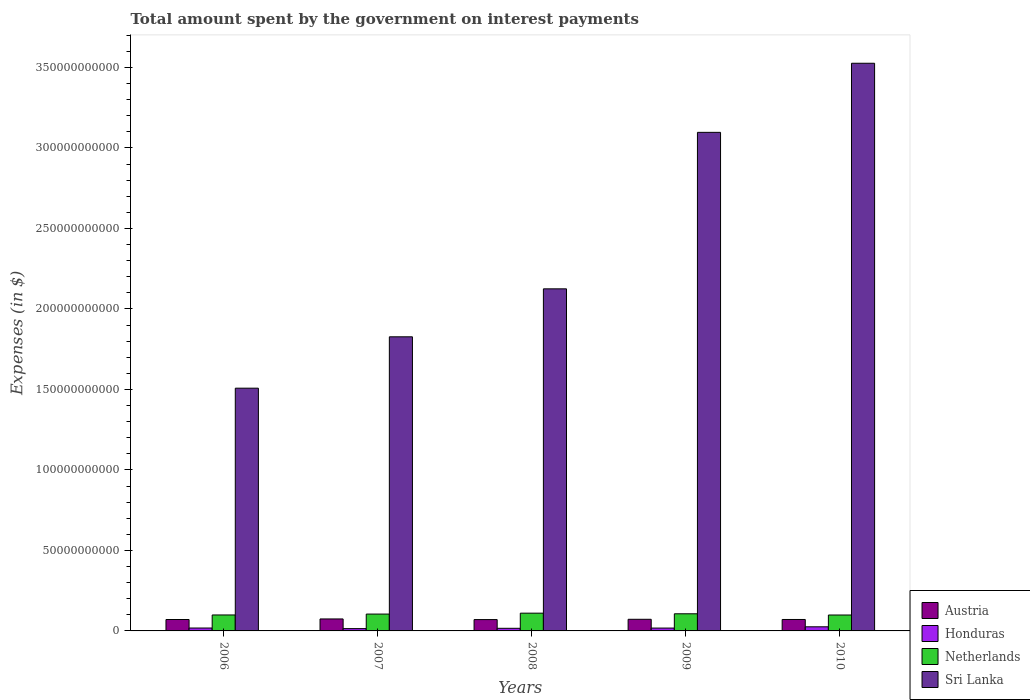How many different coloured bars are there?
Offer a very short reply. 4. Are the number of bars per tick equal to the number of legend labels?
Make the answer very short. Yes. Are the number of bars on each tick of the X-axis equal?
Provide a short and direct response. Yes. How many bars are there on the 1st tick from the left?
Your answer should be very brief. 4. How many bars are there on the 5th tick from the right?
Your answer should be compact. 4. What is the label of the 3rd group of bars from the left?
Make the answer very short. 2008. In how many cases, is the number of bars for a given year not equal to the number of legend labels?
Make the answer very short. 0. What is the amount spent on interest payments by the government in Netherlands in 2009?
Provide a short and direct response. 1.06e+1. Across all years, what is the maximum amount spent on interest payments by the government in Austria?
Your answer should be very brief. 7.44e+09. Across all years, what is the minimum amount spent on interest payments by the government in Austria?
Ensure brevity in your answer.  7.04e+09. What is the total amount spent on interest payments by the government in Sri Lanka in the graph?
Your response must be concise. 1.21e+12. What is the difference between the amount spent on interest payments by the government in Austria in 2006 and that in 2010?
Offer a terse response. -2.66e+07. What is the difference between the amount spent on interest payments by the government in Sri Lanka in 2008 and the amount spent on interest payments by the government in Honduras in 2006?
Your answer should be very brief. 2.11e+11. What is the average amount spent on interest payments by the government in Honduras per year?
Ensure brevity in your answer.  1.84e+09. In the year 2006, what is the difference between the amount spent on interest payments by the government in Honduras and amount spent on interest payments by the government in Netherlands?
Provide a succinct answer. -8.11e+09. What is the ratio of the amount spent on interest payments by the government in Austria in 2006 to that in 2009?
Keep it short and to the point. 0.98. What is the difference between the highest and the second highest amount spent on interest payments by the government in Austria?
Keep it short and to the point. 2.08e+08. What is the difference between the highest and the lowest amount spent on interest payments by the government in Netherlands?
Keep it short and to the point. 1.15e+09. In how many years, is the amount spent on interest payments by the government in Sri Lanka greater than the average amount spent on interest payments by the government in Sri Lanka taken over all years?
Keep it short and to the point. 2. What does the 2nd bar from the left in 2010 represents?
Offer a terse response. Honduras. What does the 2nd bar from the right in 2009 represents?
Provide a short and direct response. Netherlands. Is it the case that in every year, the sum of the amount spent on interest payments by the government in Sri Lanka and amount spent on interest payments by the government in Austria is greater than the amount spent on interest payments by the government in Netherlands?
Make the answer very short. Yes. Are all the bars in the graph horizontal?
Your response must be concise. No. Does the graph contain grids?
Give a very brief answer. No. Where does the legend appear in the graph?
Provide a short and direct response. Bottom right. What is the title of the graph?
Provide a short and direct response. Total amount spent by the government on interest payments. Does "Canada" appear as one of the legend labels in the graph?
Ensure brevity in your answer.  No. What is the label or title of the Y-axis?
Provide a succinct answer. Expenses (in $). What is the Expenses (in $) in Austria in 2006?
Give a very brief answer. 7.09e+09. What is the Expenses (in $) in Honduras in 2006?
Your response must be concise. 1.80e+09. What is the Expenses (in $) in Netherlands in 2006?
Make the answer very short. 9.91e+09. What is the Expenses (in $) in Sri Lanka in 2006?
Ensure brevity in your answer.  1.51e+11. What is the Expenses (in $) in Austria in 2007?
Ensure brevity in your answer.  7.44e+09. What is the Expenses (in $) in Honduras in 2007?
Your answer should be very brief. 1.43e+09. What is the Expenses (in $) of Netherlands in 2007?
Offer a very short reply. 1.05e+1. What is the Expenses (in $) of Sri Lanka in 2007?
Your answer should be compact. 1.83e+11. What is the Expenses (in $) in Austria in 2008?
Ensure brevity in your answer.  7.04e+09. What is the Expenses (in $) of Honduras in 2008?
Your answer should be compact. 1.63e+09. What is the Expenses (in $) in Netherlands in 2008?
Your answer should be very brief. 1.10e+1. What is the Expenses (in $) in Sri Lanka in 2008?
Your answer should be very brief. 2.12e+11. What is the Expenses (in $) of Austria in 2009?
Make the answer very short. 7.23e+09. What is the Expenses (in $) of Honduras in 2009?
Offer a very short reply. 1.77e+09. What is the Expenses (in $) of Netherlands in 2009?
Provide a short and direct response. 1.06e+1. What is the Expenses (in $) of Sri Lanka in 2009?
Offer a very short reply. 3.10e+11. What is the Expenses (in $) in Austria in 2010?
Make the answer very short. 7.11e+09. What is the Expenses (in $) of Honduras in 2010?
Offer a terse response. 2.55e+09. What is the Expenses (in $) in Netherlands in 2010?
Provide a succinct answer. 9.88e+09. What is the Expenses (in $) of Sri Lanka in 2010?
Your response must be concise. 3.53e+11. Across all years, what is the maximum Expenses (in $) in Austria?
Keep it short and to the point. 7.44e+09. Across all years, what is the maximum Expenses (in $) of Honduras?
Offer a terse response. 2.55e+09. Across all years, what is the maximum Expenses (in $) in Netherlands?
Your answer should be very brief. 1.10e+1. Across all years, what is the maximum Expenses (in $) of Sri Lanka?
Offer a very short reply. 3.53e+11. Across all years, what is the minimum Expenses (in $) in Austria?
Keep it short and to the point. 7.04e+09. Across all years, what is the minimum Expenses (in $) in Honduras?
Keep it short and to the point. 1.43e+09. Across all years, what is the minimum Expenses (in $) in Netherlands?
Your response must be concise. 9.88e+09. Across all years, what is the minimum Expenses (in $) in Sri Lanka?
Keep it short and to the point. 1.51e+11. What is the total Expenses (in $) of Austria in the graph?
Your response must be concise. 3.59e+1. What is the total Expenses (in $) in Honduras in the graph?
Your answer should be compact. 9.19e+09. What is the total Expenses (in $) of Netherlands in the graph?
Give a very brief answer. 5.19e+1. What is the total Expenses (in $) of Sri Lanka in the graph?
Your answer should be very brief. 1.21e+12. What is the difference between the Expenses (in $) in Austria in 2006 and that in 2007?
Make the answer very short. -3.51e+08. What is the difference between the Expenses (in $) in Honduras in 2006 and that in 2007?
Offer a terse response. 3.70e+08. What is the difference between the Expenses (in $) in Netherlands in 2006 and that in 2007?
Your response must be concise. -5.60e+08. What is the difference between the Expenses (in $) of Sri Lanka in 2006 and that in 2007?
Your answer should be compact. -3.19e+1. What is the difference between the Expenses (in $) of Austria in 2006 and that in 2008?
Give a very brief answer. 4.10e+07. What is the difference between the Expenses (in $) in Honduras in 2006 and that in 2008?
Provide a succinct answer. 1.78e+08. What is the difference between the Expenses (in $) of Netherlands in 2006 and that in 2008?
Provide a short and direct response. -1.12e+09. What is the difference between the Expenses (in $) in Sri Lanka in 2006 and that in 2008?
Your response must be concise. -6.17e+1. What is the difference between the Expenses (in $) in Austria in 2006 and that in 2009?
Your answer should be very brief. -1.43e+08. What is the difference between the Expenses (in $) of Honduras in 2006 and that in 2009?
Your response must be concise. 2.83e+07. What is the difference between the Expenses (in $) of Netherlands in 2006 and that in 2009?
Provide a succinct answer. -7.34e+08. What is the difference between the Expenses (in $) of Sri Lanka in 2006 and that in 2009?
Provide a succinct answer. -1.59e+11. What is the difference between the Expenses (in $) in Austria in 2006 and that in 2010?
Ensure brevity in your answer.  -2.66e+07. What is the difference between the Expenses (in $) in Honduras in 2006 and that in 2010?
Your answer should be compact. -7.51e+08. What is the difference between the Expenses (in $) in Netherlands in 2006 and that in 2010?
Make the answer very short. 2.60e+07. What is the difference between the Expenses (in $) of Sri Lanka in 2006 and that in 2010?
Your response must be concise. -2.02e+11. What is the difference between the Expenses (in $) of Austria in 2007 and that in 2008?
Make the answer very short. 3.92e+08. What is the difference between the Expenses (in $) in Honduras in 2007 and that in 2008?
Provide a succinct answer. -1.92e+08. What is the difference between the Expenses (in $) of Netherlands in 2007 and that in 2008?
Provide a short and direct response. -5.60e+08. What is the difference between the Expenses (in $) in Sri Lanka in 2007 and that in 2008?
Ensure brevity in your answer.  -2.98e+1. What is the difference between the Expenses (in $) of Austria in 2007 and that in 2009?
Provide a short and direct response. 2.08e+08. What is the difference between the Expenses (in $) in Honduras in 2007 and that in 2009?
Your answer should be compact. -3.41e+08. What is the difference between the Expenses (in $) in Netherlands in 2007 and that in 2009?
Your answer should be compact. -1.74e+08. What is the difference between the Expenses (in $) of Sri Lanka in 2007 and that in 2009?
Your answer should be very brief. -1.27e+11. What is the difference between the Expenses (in $) of Austria in 2007 and that in 2010?
Your answer should be compact. 3.25e+08. What is the difference between the Expenses (in $) of Honduras in 2007 and that in 2010?
Offer a terse response. -1.12e+09. What is the difference between the Expenses (in $) of Netherlands in 2007 and that in 2010?
Your response must be concise. 5.86e+08. What is the difference between the Expenses (in $) in Sri Lanka in 2007 and that in 2010?
Ensure brevity in your answer.  -1.70e+11. What is the difference between the Expenses (in $) in Austria in 2008 and that in 2009?
Provide a succinct answer. -1.84e+08. What is the difference between the Expenses (in $) of Honduras in 2008 and that in 2009?
Your answer should be compact. -1.49e+08. What is the difference between the Expenses (in $) in Netherlands in 2008 and that in 2009?
Your answer should be compact. 3.86e+08. What is the difference between the Expenses (in $) in Sri Lanka in 2008 and that in 2009?
Ensure brevity in your answer.  -9.72e+1. What is the difference between the Expenses (in $) in Austria in 2008 and that in 2010?
Make the answer very short. -6.76e+07. What is the difference between the Expenses (in $) of Honduras in 2008 and that in 2010?
Keep it short and to the point. -9.29e+08. What is the difference between the Expenses (in $) of Netherlands in 2008 and that in 2010?
Ensure brevity in your answer.  1.15e+09. What is the difference between the Expenses (in $) in Sri Lanka in 2008 and that in 2010?
Offer a very short reply. -1.40e+11. What is the difference between the Expenses (in $) in Austria in 2009 and that in 2010?
Provide a short and direct response. 1.17e+08. What is the difference between the Expenses (in $) in Honduras in 2009 and that in 2010?
Your response must be concise. -7.80e+08. What is the difference between the Expenses (in $) in Netherlands in 2009 and that in 2010?
Give a very brief answer. 7.60e+08. What is the difference between the Expenses (in $) of Sri Lanka in 2009 and that in 2010?
Ensure brevity in your answer.  -4.29e+1. What is the difference between the Expenses (in $) of Austria in 2006 and the Expenses (in $) of Honduras in 2007?
Ensure brevity in your answer.  5.65e+09. What is the difference between the Expenses (in $) in Austria in 2006 and the Expenses (in $) in Netherlands in 2007?
Keep it short and to the point. -3.39e+09. What is the difference between the Expenses (in $) in Austria in 2006 and the Expenses (in $) in Sri Lanka in 2007?
Give a very brief answer. -1.76e+11. What is the difference between the Expenses (in $) of Honduras in 2006 and the Expenses (in $) of Netherlands in 2007?
Provide a short and direct response. -8.67e+09. What is the difference between the Expenses (in $) in Honduras in 2006 and the Expenses (in $) in Sri Lanka in 2007?
Provide a succinct answer. -1.81e+11. What is the difference between the Expenses (in $) of Netherlands in 2006 and the Expenses (in $) of Sri Lanka in 2007?
Make the answer very short. -1.73e+11. What is the difference between the Expenses (in $) in Austria in 2006 and the Expenses (in $) in Honduras in 2008?
Keep it short and to the point. 5.46e+09. What is the difference between the Expenses (in $) in Austria in 2006 and the Expenses (in $) in Netherlands in 2008?
Ensure brevity in your answer.  -3.95e+09. What is the difference between the Expenses (in $) in Austria in 2006 and the Expenses (in $) in Sri Lanka in 2008?
Offer a very short reply. -2.05e+11. What is the difference between the Expenses (in $) of Honduras in 2006 and the Expenses (in $) of Netherlands in 2008?
Provide a succinct answer. -9.23e+09. What is the difference between the Expenses (in $) of Honduras in 2006 and the Expenses (in $) of Sri Lanka in 2008?
Ensure brevity in your answer.  -2.11e+11. What is the difference between the Expenses (in $) of Netherlands in 2006 and the Expenses (in $) of Sri Lanka in 2008?
Offer a terse response. -2.03e+11. What is the difference between the Expenses (in $) of Austria in 2006 and the Expenses (in $) of Honduras in 2009?
Offer a very short reply. 5.31e+09. What is the difference between the Expenses (in $) of Austria in 2006 and the Expenses (in $) of Netherlands in 2009?
Make the answer very short. -3.56e+09. What is the difference between the Expenses (in $) of Austria in 2006 and the Expenses (in $) of Sri Lanka in 2009?
Your response must be concise. -3.03e+11. What is the difference between the Expenses (in $) of Honduras in 2006 and the Expenses (in $) of Netherlands in 2009?
Keep it short and to the point. -8.84e+09. What is the difference between the Expenses (in $) of Honduras in 2006 and the Expenses (in $) of Sri Lanka in 2009?
Provide a succinct answer. -3.08e+11. What is the difference between the Expenses (in $) in Netherlands in 2006 and the Expenses (in $) in Sri Lanka in 2009?
Ensure brevity in your answer.  -3.00e+11. What is the difference between the Expenses (in $) of Austria in 2006 and the Expenses (in $) of Honduras in 2010?
Give a very brief answer. 4.53e+09. What is the difference between the Expenses (in $) in Austria in 2006 and the Expenses (in $) in Netherlands in 2010?
Give a very brief answer. -2.80e+09. What is the difference between the Expenses (in $) in Austria in 2006 and the Expenses (in $) in Sri Lanka in 2010?
Keep it short and to the point. -3.46e+11. What is the difference between the Expenses (in $) in Honduras in 2006 and the Expenses (in $) in Netherlands in 2010?
Offer a terse response. -8.08e+09. What is the difference between the Expenses (in $) in Honduras in 2006 and the Expenses (in $) in Sri Lanka in 2010?
Provide a short and direct response. -3.51e+11. What is the difference between the Expenses (in $) in Netherlands in 2006 and the Expenses (in $) in Sri Lanka in 2010?
Offer a terse response. -3.43e+11. What is the difference between the Expenses (in $) of Austria in 2007 and the Expenses (in $) of Honduras in 2008?
Offer a very short reply. 5.81e+09. What is the difference between the Expenses (in $) in Austria in 2007 and the Expenses (in $) in Netherlands in 2008?
Your answer should be very brief. -3.59e+09. What is the difference between the Expenses (in $) in Austria in 2007 and the Expenses (in $) in Sri Lanka in 2008?
Ensure brevity in your answer.  -2.05e+11. What is the difference between the Expenses (in $) of Honduras in 2007 and the Expenses (in $) of Netherlands in 2008?
Keep it short and to the point. -9.60e+09. What is the difference between the Expenses (in $) of Honduras in 2007 and the Expenses (in $) of Sri Lanka in 2008?
Offer a terse response. -2.11e+11. What is the difference between the Expenses (in $) of Netherlands in 2007 and the Expenses (in $) of Sri Lanka in 2008?
Provide a succinct answer. -2.02e+11. What is the difference between the Expenses (in $) in Austria in 2007 and the Expenses (in $) in Honduras in 2009?
Offer a terse response. 5.66e+09. What is the difference between the Expenses (in $) in Austria in 2007 and the Expenses (in $) in Netherlands in 2009?
Your response must be concise. -3.21e+09. What is the difference between the Expenses (in $) of Austria in 2007 and the Expenses (in $) of Sri Lanka in 2009?
Make the answer very short. -3.02e+11. What is the difference between the Expenses (in $) of Honduras in 2007 and the Expenses (in $) of Netherlands in 2009?
Give a very brief answer. -9.21e+09. What is the difference between the Expenses (in $) in Honduras in 2007 and the Expenses (in $) in Sri Lanka in 2009?
Your response must be concise. -3.08e+11. What is the difference between the Expenses (in $) of Netherlands in 2007 and the Expenses (in $) of Sri Lanka in 2009?
Give a very brief answer. -2.99e+11. What is the difference between the Expenses (in $) in Austria in 2007 and the Expenses (in $) in Honduras in 2010?
Offer a very short reply. 4.88e+09. What is the difference between the Expenses (in $) of Austria in 2007 and the Expenses (in $) of Netherlands in 2010?
Your response must be concise. -2.45e+09. What is the difference between the Expenses (in $) in Austria in 2007 and the Expenses (in $) in Sri Lanka in 2010?
Provide a succinct answer. -3.45e+11. What is the difference between the Expenses (in $) of Honduras in 2007 and the Expenses (in $) of Netherlands in 2010?
Your answer should be very brief. -8.45e+09. What is the difference between the Expenses (in $) of Honduras in 2007 and the Expenses (in $) of Sri Lanka in 2010?
Your answer should be compact. -3.51e+11. What is the difference between the Expenses (in $) in Netherlands in 2007 and the Expenses (in $) in Sri Lanka in 2010?
Your answer should be compact. -3.42e+11. What is the difference between the Expenses (in $) of Austria in 2008 and the Expenses (in $) of Honduras in 2009?
Your response must be concise. 5.27e+09. What is the difference between the Expenses (in $) in Austria in 2008 and the Expenses (in $) in Netherlands in 2009?
Provide a succinct answer. -3.60e+09. What is the difference between the Expenses (in $) in Austria in 2008 and the Expenses (in $) in Sri Lanka in 2009?
Give a very brief answer. -3.03e+11. What is the difference between the Expenses (in $) of Honduras in 2008 and the Expenses (in $) of Netherlands in 2009?
Offer a terse response. -9.02e+09. What is the difference between the Expenses (in $) of Honduras in 2008 and the Expenses (in $) of Sri Lanka in 2009?
Your response must be concise. -3.08e+11. What is the difference between the Expenses (in $) of Netherlands in 2008 and the Expenses (in $) of Sri Lanka in 2009?
Offer a terse response. -2.99e+11. What is the difference between the Expenses (in $) in Austria in 2008 and the Expenses (in $) in Honduras in 2010?
Keep it short and to the point. 4.49e+09. What is the difference between the Expenses (in $) of Austria in 2008 and the Expenses (in $) of Netherlands in 2010?
Make the answer very short. -2.84e+09. What is the difference between the Expenses (in $) in Austria in 2008 and the Expenses (in $) in Sri Lanka in 2010?
Keep it short and to the point. -3.46e+11. What is the difference between the Expenses (in $) of Honduras in 2008 and the Expenses (in $) of Netherlands in 2010?
Offer a terse response. -8.26e+09. What is the difference between the Expenses (in $) in Honduras in 2008 and the Expenses (in $) in Sri Lanka in 2010?
Offer a very short reply. -3.51e+11. What is the difference between the Expenses (in $) in Netherlands in 2008 and the Expenses (in $) in Sri Lanka in 2010?
Provide a short and direct response. -3.42e+11. What is the difference between the Expenses (in $) of Austria in 2009 and the Expenses (in $) of Honduras in 2010?
Offer a very short reply. 4.67e+09. What is the difference between the Expenses (in $) in Austria in 2009 and the Expenses (in $) in Netherlands in 2010?
Keep it short and to the point. -2.66e+09. What is the difference between the Expenses (in $) in Austria in 2009 and the Expenses (in $) in Sri Lanka in 2010?
Your answer should be compact. -3.45e+11. What is the difference between the Expenses (in $) of Honduras in 2009 and the Expenses (in $) of Netherlands in 2010?
Your answer should be very brief. -8.11e+09. What is the difference between the Expenses (in $) of Honduras in 2009 and the Expenses (in $) of Sri Lanka in 2010?
Your answer should be very brief. -3.51e+11. What is the difference between the Expenses (in $) of Netherlands in 2009 and the Expenses (in $) of Sri Lanka in 2010?
Your response must be concise. -3.42e+11. What is the average Expenses (in $) in Austria per year?
Offer a terse response. 7.18e+09. What is the average Expenses (in $) in Honduras per year?
Offer a terse response. 1.84e+09. What is the average Expenses (in $) of Netherlands per year?
Make the answer very short. 1.04e+1. What is the average Expenses (in $) in Sri Lanka per year?
Your answer should be compact. 2.42e+11. In the year 2006, what is the difference between the Expenses (in $) in Austria and Expenses (in $) in Honduras?
Provide a short and direct response. 5.28e+09. In the year 2006, what is the difference between the Expenses (in $) of Austria and Expenses (in $) of Netherlands?
Your response must be concise. -2.83e+09. In the year 2006, what is the difference between the Expenses (in $) in Austria and Expenses (in $) in Sri Lanka?
Ensure brevity in your answer.  -1.44e+11. In the year 2006, what is the difference between the Expenses (in $) of Honduras and Expenses (in $) of Netherlands?
Provide a succinct answer. -8.11e+09. In the year 2006, what is the difference between the Expenses (in $) of Honduras and Expenses (in $) of Sri Lanka?
Offer a terse response. -1.49e+11. In the year 2006, what is the difference between the Expenses (in $) in Netherlands and Expenses (in $) in Sri Lanka?
Make the answer very short. -1.41e+11. In the year 2007, what is the difference between the Expenses (in $) of Austria and Expenses (in $) of Honduras?
Offer a terse response. 6.00e+09. In the year 2007, what is the difference between the Expenses (in $) in Austria and Expenses (in $) in Netherlands?
Offer a terse response. -3.03e+09. In the year 2007, what is the difference between the Expenses (in $) in Austria and Expenses (in $) in Sri Lanka?
Give a very brief answer. -1.75e+11. In the year 2007, what is the difference between the Expenses (in $) of Honduras and Expenses (in $) of Netherlands?
Offer a terse response. -9.04e+09. In the year 2007, what is the difference between the Expenses (in $) of Honduras and Expenses (in $) of Sri Lanka?
Your answer should be compact. -1.81e+11. In the year 2007, what is the difference between the Expenses (in $) of Netherlands and Expenses (in $) of Sri Lanka?
Ensure brevity in your answer.  -1.72e+11. In the year 2008, what is the difference between the Expenses (in $) of Austria and Expenses (in $) of Honduras?
Your response must be concise. 5.42e+09. In the year 2008, what is the difference between the Expenses (in $) in Austria and Expenses (in $) in Netherlands?
Provide a succinct answer. -3.99e+09. In the year 2008, what is the difference between the Expenses (in $) in Austria and Expenses (in $) in Sri Lanka?
Keep it short and to the point. -2.05e+11. In the year 2008, what is the difference between the Expenses (in $) of Honduras and Expenses (in $) of Netherlands?
Give a very brief answer. -9.41e+09. In the year 2008, what is the difference between the Expenses (in $) in Honduras and Expenses (in $) in Sri Lanka?
Give a very brief answer. -2.11e+11. In the year 2008, what is the difference between the Expenses (in $) of Netherlands and Expenses (in $) of Sri Lanka?
Give a very brief answer. -2.01e+11. In the year 2009, what is the difference between the Expenses (in $) in Austria and Expenses (in $) in Honduras?
Provide a short and direct response. 5.45e+09. In the year 2009, what is the difference between the Expenses (in $) of Austria and Expenses (in $) of Netherlands?
Provide a succinct answer. -3.42e+09. In the year 2009, what is the difference between the Expenses (in $) of Austria and Expenses (in $) of Sri Lanka?
Your response must be concise. -3.02e+11. In the year 2009, what is the difference between the Expenses (in $) in Honduras and Expenses (in $) in Netherlands?
Your response must be concise. -8.87e+09. In the year 2009, what is the difference between the Expenses (in $) in Honduras and Expenses (in $) in Sri Lanka?
Make the answer very short. -3.08e+11. In the year 2009, what is the difference between the Expenses (in $) in Netherlands and Expenses (in $) in Sri Lanka?
Your answer should be compact. -2.99e+11. In the year 2010, what is the difference between the Expenses (in $) of Austria and Expenses (in $) of Honduras?
Your response must be concise. 4.56e+09. In the year 2010, what is the difference between the Expenses (in $) in Austria and Expenses (in $) in Netherlands?
Offer a terse response. -2.77e+09. In the year 2010, what is the difference between the Expenses (in $) in Austria and Expenses (in $) in Sri Lanka?
Your answer should be very brief. -3.45e+11. In the year 2010, what is the difference between the Expenses (in $) in Honduras and Expenses (in $) in Netherlands?
Provide a short and direct response. -7.33e+09. In the year 2010, what is the difference between the Expenses (in $) in Honduras and Expenses (in $) in Sri Lanka?
Your response must be concise. -3.50e+11. In the year 2010, what is the difference between the Expenses (in $) in Netherlands and Expenses (in $) in Sri Lanka?
Make the answer very short. -3.43e+11. What is the ratio of the Expenses (in $) of Austria in 2006 to that in 2007?
Your response must be concise. 0.95. What is the ratio of the Expenses (in $) of Honduras in 2006 to that in 2007?
Offer a terse response. 1.26. What is the ratio of the Expenses (in $) of Netherlands in 2006 to that in 2007?
Give a very brief answer. 0.95. What is the ratio of the Expenses (in $) in Sri Lanka in 2006 to that in 2007?
Give a very brief answer. 0.83. What is the ratio of the Expenses (in $) in Austria in 2006 to that in 2008?
Keep it short and to the point. 1.01. What is the ratio of the Expenses (in $) of Honduras in 2006 to that in 2008?
Keep it short and to the point. 1.11. What is the ratio of the Expenses (in $) of Netherlands in 2006 to that in 2008?
Ensure brevity in your answer.  0.9. What is the ratio of the Expenses (in $) of Sri Lanka in 2006 to that in 2008?
Provide a succinct answer. 0.71. What is the ratio of the Expenses (in $) in Austria in 2006 to that in 2009?
Provide a short and direct response. 0.98. What is the ratio of the Expenses (in $) of Honduras in 2006 to that in 2009?
Ensure brevity in your answer.  1.02. What is the ratio of the Expenses (in $) of Netherlands in 2006 to that in 2009?
Provide a succinct answer. 0.93. What is the ratio of the Expenses (in $) in Sri Lanka in 2006 to that in 2009?
Make the answer very short. 0.49. What is the ratio of the Expenses (in $) in Honduras in 2006 to that in 2010?
Offer a terse response. 0.71. What is the ratio of the Expenses (in $) of Netherlands in 2006 to that in 2010?
Ensure brevity in your answer.  1. What is the ratio of the Expenses (in $) of Sri Lanka in 2006 to that in 2010?
Offer a terse response. 0.43. What is the ratio of the Expenses (in $) in Austria in 2007 to that in 2008?
Offer a terse response. 1.06. What is the ratio of the Expenses (in $) in Honduras in 2007 to that in 2008?
Give a very brief answer. 0.88. What is the ratio of the Expenses (in $) in Netherlands in 2007 to that in 2008?
Offer a terse response. 0.95. What is the ratio of the Expenses (in $) of Sri Lanka in 2007 to that in 2008?
Your answer should be compact. 0.86. What is the ratio of the Expenses (in $) of Austria in 2007 to that in 2009?
Ensure brevity in your answer.  1.03. What is the ratio of the Expenses (in $) in Honduras in 2007 to that in 2009?
Provide a short and direct response. 0.81. What is the ratio of the Expenses (in $) of Netherlands in 2007 to that in 2009?
Offer a terse response. 0.98. What is the ratio of the Expenses (in $) of Sri Lanka in 2007 to that in 2009?
Ensure brevity in your answer.  0.59. What is the ratio of the Expenses (in $) of Austria in 2007 to that in 2010?
Your response must be concise. 1.05. What is the ratio of the Expenses (in $) of Honduras in 2007 to that in 2010?
Make the answer very short. 0.56. What is the ratio of the Expenses (in $) of Netherlands in 2007 to that in 2010?
Your response must be concise. 1.06. What is the ratio of the Expenses (in $) in Sri Lanka in 2007 to that in 2010?
Provide a succinct answer. 0.52. What is the ratio of the Expenses (in $) in Austria in 2008 to that in 2009?
Keep it short and to the point. 0.97. What is the ratio of the Expenses (in $) in Honduras in 2008 to that in 2009?
Offer a very short reply. 0.92. What is the ratio of the Expenses (in $) in Netherlands in 2008 to that in 2009?
Your response must be concise. 1.04. What is the ratio of the Expenses (in $) of Sri Lanka in 2008 to that in 2009?
Keep it short and to the point. 0.69. What is the ratio of the Expenses (in $) in Austria in 2008 to that in 2010?
Offer a very short reply. 0.99. What is the ratio of the Expenses (in $) in Honduras in 2008 to that in 2010?
Provide a succinct answer. 0.64. What is the ratio of the Expenses (in $) of Netherlands in 2008 to that in 2010?
Keep it short and to the point. 1.12. What is the ratio of the Expenses (in $) in Sri Lanka in 2008 to that in 2010?
Your answer should be compact. 0.6. What is the ratio of the Expenses (in $) in Austria in 2009 to that in 2010?
Keep it short and to the point. 1.02. What is the ratio of the Expenses (in $) of Honduras in 2009 to that in 2010?
Provide a short and direct response. 0.69. What is the ratio of the Expenses (in $) of Netherlands in 2009 to that in 2010?
Make the answer very short. 1.08. What is the ratio of the Expenses (in $) in Sri Lanka in 2009 to that in 2010?
Offer a terse response. 0.88. What is the difference between the highest and the second highest Expenses (in $) of Austria?
Offer a terse response. 2.08e+08. What is the difference between the highest and the second highest Expenses (in $) of Honduras?
Provide a succinct answer. 7.51e+08. What is the difference between the highest and the second highest Expenses (in $) in Netherlands?
Your answer should be compact. 3.86e+08. What is the difference between the highest and the second highest Expenses (in $) of Sri Lanka?
Provide a succinct answer. 4.29e+1. What is the difference between the highest and the lowest Expenses (in $) of Austria?
Make the answer very short. 3.92e+08. What is the difference between the highest and the lowest Expenses (in $) in Honduras?
Provide a short and direct response. 1.12e+09. What is the difference between the highest and the lowest Expenses (in $) of Netherlands?
Provide a succinct answer. 1.15e+09. What is the difference between the highest and the lowest Expenses (in $) of Sri Lanka?
Offer a terse response. 2.02e+11. 